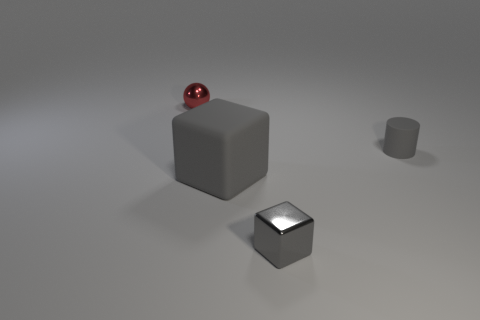There is a shiny object on the right side of the red thing; is its size the same as the big gray rubber object?
Your response must be concise. No. Are there fewer rubber objects that are behind the large cube than shiny objects?
Provide a succinct answer. Yes. What is the material of the gray block that is the same size as the red shiny ball?
Give a very brief answer. Metal. How many tiny objects are green matte cubes or gray objects?
Your response must be concise. 2. What number of objects are small gray objects on the right side of the small gray metal object or cylinders that are in front of the small shiny sphere?
Make the answer very short. 1. Are there fewer big brown shiny things than small shiny objects?
Provide a succinct answer. Yes. What shape is the gray rubber object that is the same size as the red metallic thing?
Keep it short and to the point. Cylinder. What number of other objects are the same color as the tiny cylinder?
Give a very brief answer. 2. What number of blue cylinders are there?
Offer a very short reply. 0. How many objects are both left of the small metallic cube and in front of the gray rubber cylinder?
Make the answer very short. 1. 